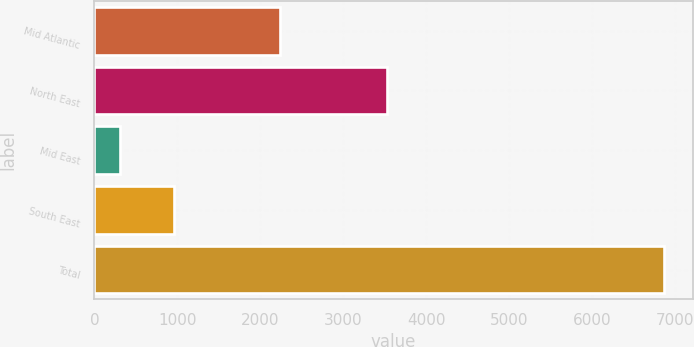<chart> <loc_0><loc_0><loc_500><loc_500><bar_chart><fcel>Mid Atlantic<fcel>North East<fcel>Mid East<fcel>South East<fcel>Total<nl><fcel>2240<fcel>3530<fcel>303<fcel>959.1<fcel>6864<nl></chart> 